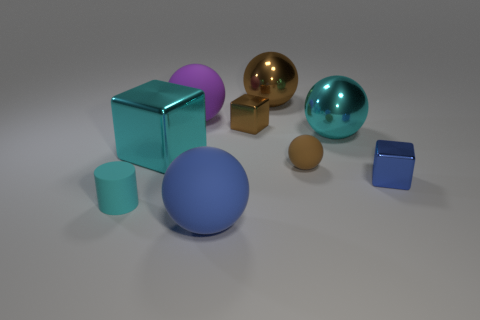The block that is the same size as the cyan ball is what color? Upon examining the image, the block that matches the size of the cyan-colored ball appears to be the golden-yellow cube located near the center. 